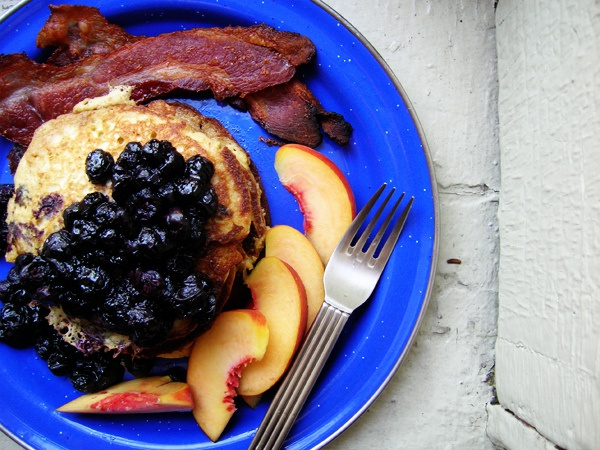Describe the objects in this image and their specific colors. I can see fork in lightgray, gray, darkgray, and black tones and apple in lightgray, brown, salmon, tan, and red tones in this image. 